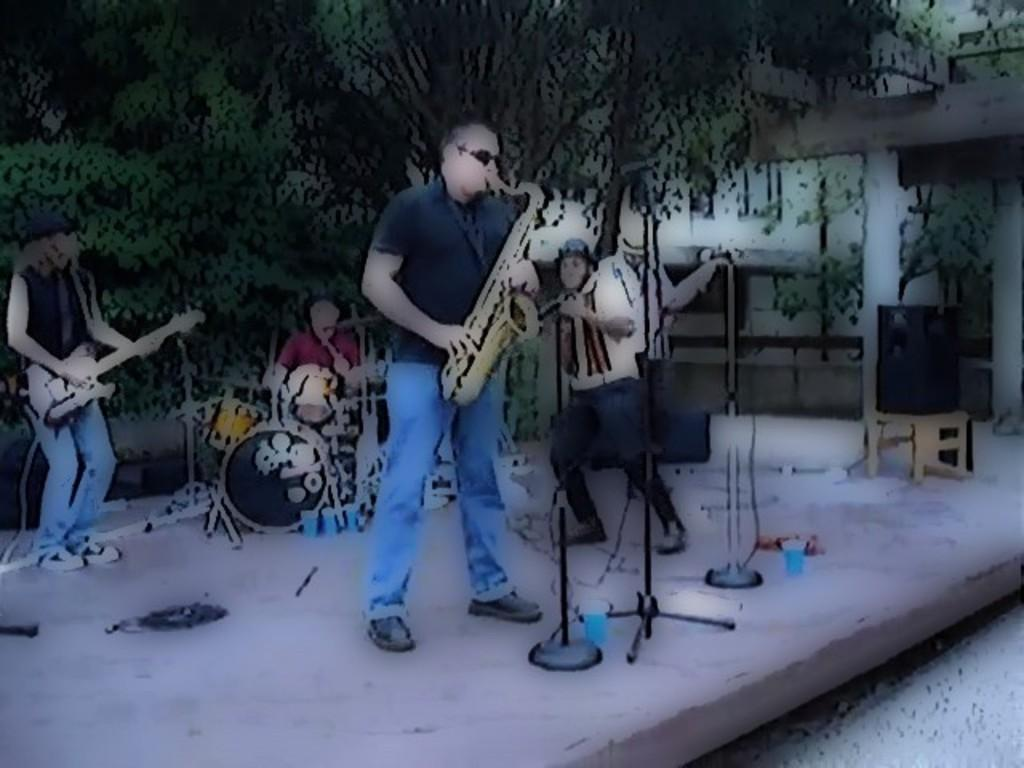How many people are in the image? There are few persons in the image. What are the persons in the image doing? The persons are playing musical instruments. Can you describe the background of the image? There are trees in the background of the image. What is at the bottom of the image? There is a floor at the bottom of the image. Are there any fairies playing musical instruments in the image? There are no fairies present in the image; it features persons playing musical instruments. 